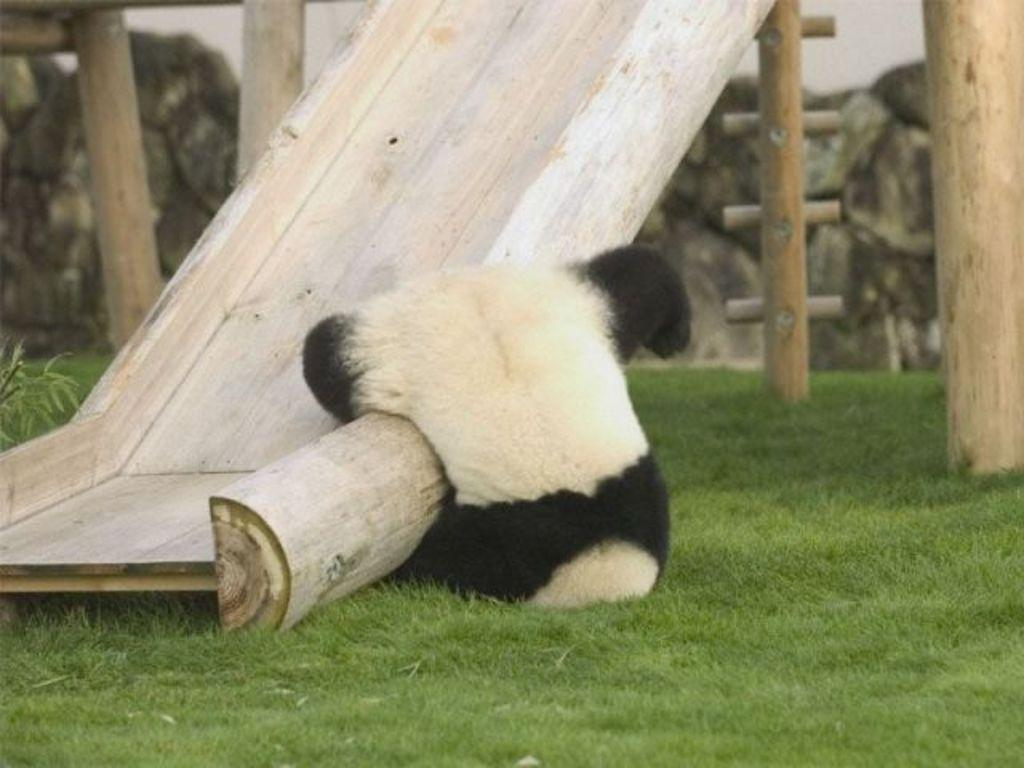What type of animal is in the image? There is a panda in the image. What playground equipment is present in the image? There is a wooden slide in the image. What structures can be seen supporting the slide or other playground equipment? There are poles visible in the image. What type of surface covers the ground in the image? The ground is covered with grass in the image. What type of barrier or boundary is present in the image? There is a wall in the image. How far does the panda expand its territory in the image? The image does not depict the panda's territory or any expansion of it. 